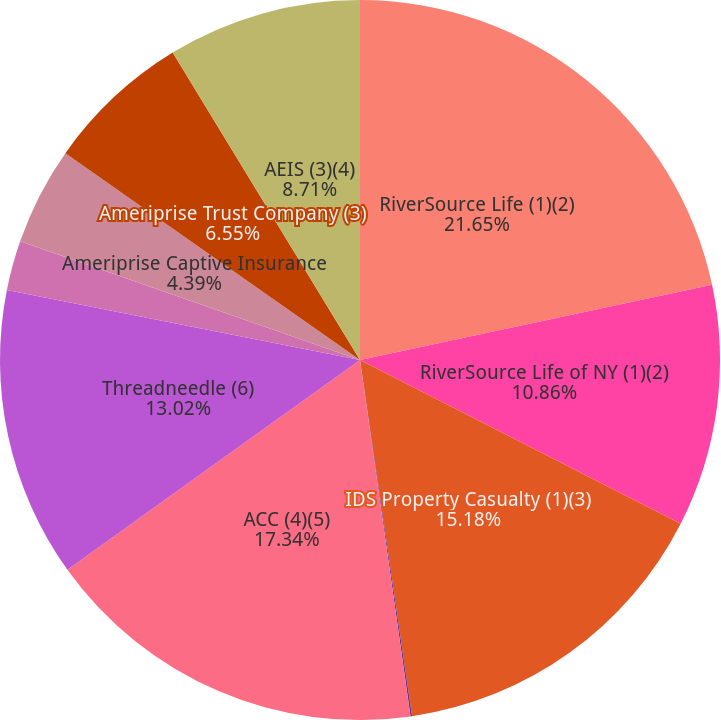Convert chart to OTSL. <chart><loc_0><loc_0><loc_500><loc_500><pie_chart><fcel>RiverSource Life (1)(2)<fcel>RiverSource Life of NY (1)(2)<fcel>IDS Property Casualty (1)(3)<fcel>Ameriprise Insurance Company<fcel>ACC (4)(5)<fcel>Threadneedle (6)<fcel>Ameriprise National Trust Bank<fcel>Ameriprise Captive Insurance<fcel>Ameriprise Trust Company (3)<fcel>AEIS (3)(4)<nl><fcel>21.65%<fcel>10.86%<fcel>15.18%<fcel>0.07%<fcel>17.34%<fcel>13.02%<fcel>2.23%<fcel>4.39%<fcel>6.55%<fcel>8.71%<nl></chart> 